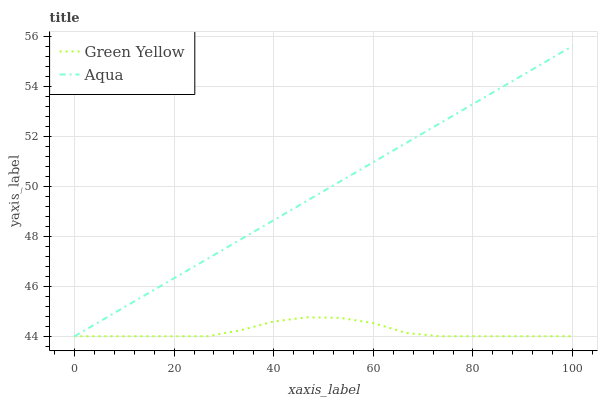Does Aqua have the minimum area under the curve?
Answer yes or no. No. Is Aqua the roughest?
Answer yes or no. No. 